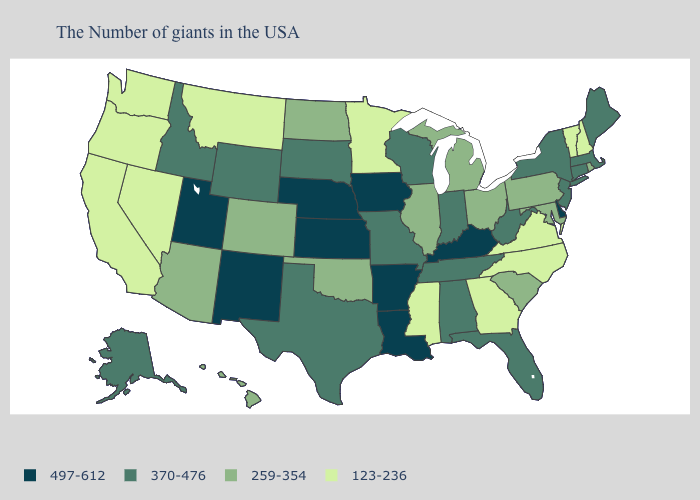Does Oklahoma have the highest value in the South?
Keep it brief. No. Among the states that border New Jersey , does Pennsylvania have the highest value?
Quick response, please. No. How many symbols are there in the legend?
Short answer required. 4. What is the value of Alaska?
Answer briefly. 370-476. Which states have the highest value in the USA?
Be succinct. Delaware, Kentucky, Louisiana, Arkansas, Iowa, Kansas, Nebraska, New Mexico, Utah. What is the value of West Virginia?
Short answer required. 370-476. What is the lowest value in the West?
Quick response, please. 123-236. What is the lowest value in the MidWest?
Write a very short answer. 123-236. Which states have the lowest value in the USA?
Give a very brief answer. New Hampshire, Vermont, Virginia, North Carolina, Georgia, Mississippi, Minnesota, Montana, Nevada, California, Washington, Oregon. What is the value of Georgia?
Short answer required. 123-236. What is the highest value in the USA?
Be succinct. 497-612. What is the lowest value in the USA?
Write a very short answer. 123-236. Among the states that border Virginia , does Kentucky have the highest value?
Give a very brief answer. Yes. Does New Hampshire have the lowest value in the Northeast?
Answer briefly. Yes. What is the highest value in the Northeast ?
Short answer required. 370-476. 